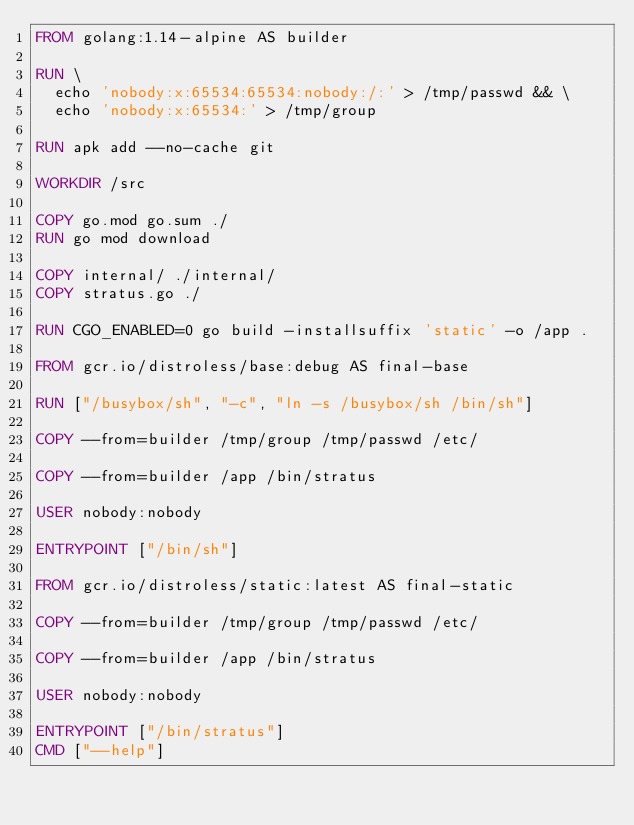<code> <loc_0><loc_0><loc_500><loc_500><_Dockerfile_>FROM golang:1.14-alpine AS builder

RUN \
  echo 'nobody:x:65534:65534:nobody:/:' > /tmp/passwd && \
  echo 'nobody:x:65534:' > /tmp/group

RUN apk add --no-cache git

WORKDIR /src

COPY go.mod go.sum ./
RUN go mod download

COPY internal/ ./internal/
COPY stratus.go ./

RUN CGO_ENABLED=0 go build -installsuffix 'static' -o /app .

FROM gcr.io/distroless/base:debug AS final-base

RUN ["/busybox/sh", "-c", "ln -s /busybox/sh /bin/sh"]

COPY --from=builder /tmp/group /tmp/passwd /etc/

COPY --from=builder /app /bin/stratus

USER nobody:nobody

ENTRYPOINT ["/bin/sh"]

FROM gcr.io/distroless/static:latest AS final-static

COPY --from=builder /tmp/group /tmp/passwd /etc/

COPY --from=builder /app /bin/stratus

USER nobody:nobody

ENTRYPOINT ["/bin/stratus"]
CMD ["--help"]
</code> 